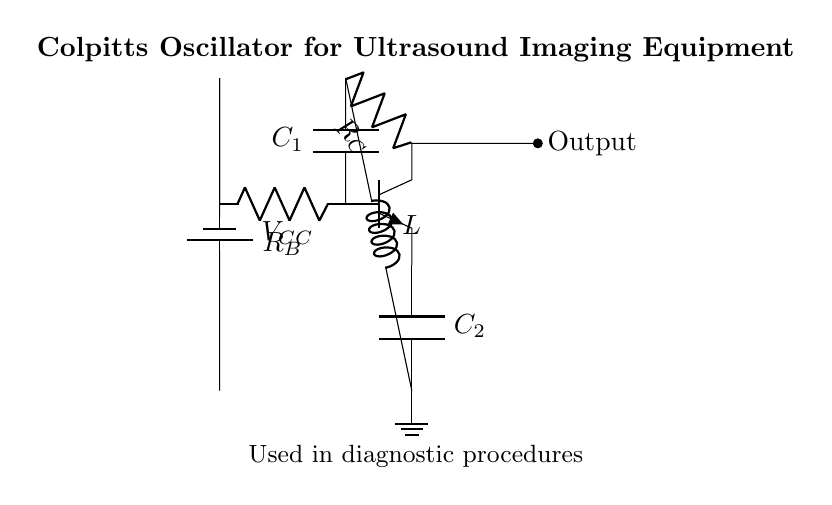What type of transistor is used in this circuit? The circuit uses an NPN transistor, which is indicated by the labeling of the transistor symbol in the diagram. NPN transistors have three regions: the collector, base, and emitter, allowing current flow from collector to emitter when a suitable voltage is applied to the base.
Answer: NPN What is the value of the capacitor labeled C1? The specific value of capacitor C1 is not provided within the diagram itself; rather, it is represented symbolically. This means without explicit values in the circuit, we cannot determine the capacitance.
Answer: Not specified What role does the inductor play in this oscillator circuit? The inductor, represented by L, is used to create a resonant circuit in conjunction with the capacitors. It helps generate the oscillation frequency by storing energy in a magnetic field, influencing the timing and frequency of the oscillator's output.
Answer: Generates oscillation frequency What is the purpose of the resistor labeled R_C? Resistor R_C is connected to the collector of the transistor and impacts the stability and gain of the oscillator circuit. It helps control the current flow through the collector and hence regulates the overall performance of the oscillator, playing a crucial role in determining its frequency response.
Answer: Regulates performance What kind of feedback mechanism is used in a Colpitts oscillator? The Colpitts oscillator uses voltage feedback through capacitors, specifically C1 and C2, to maintain oscillations. These capacitors form a voltage divider that feeds a portion of the output back to the base, sustaining oscillation without decay.
Answer: Capacitive feedback What is the expected output type of this Colpitts oscillator? The output of the Colpitts oscillator is typically a sine wave, due to the oscillations created in the circuit. The resonant nature of the circuit allows for smooth periodic oscillations, which are crucial in applications like ultrasound imaging.
Answer: Sine wave What does the power supply labeled V_CC provide in this circuit? The power supply V_CC provides the necessary voltage to activate the circuit and allow the transistor to conduct. This supply is crucial for powering the oscillator's components, ensuring that the transistor can operate and generate the desired output signal.
Answer: Power supply voltage 